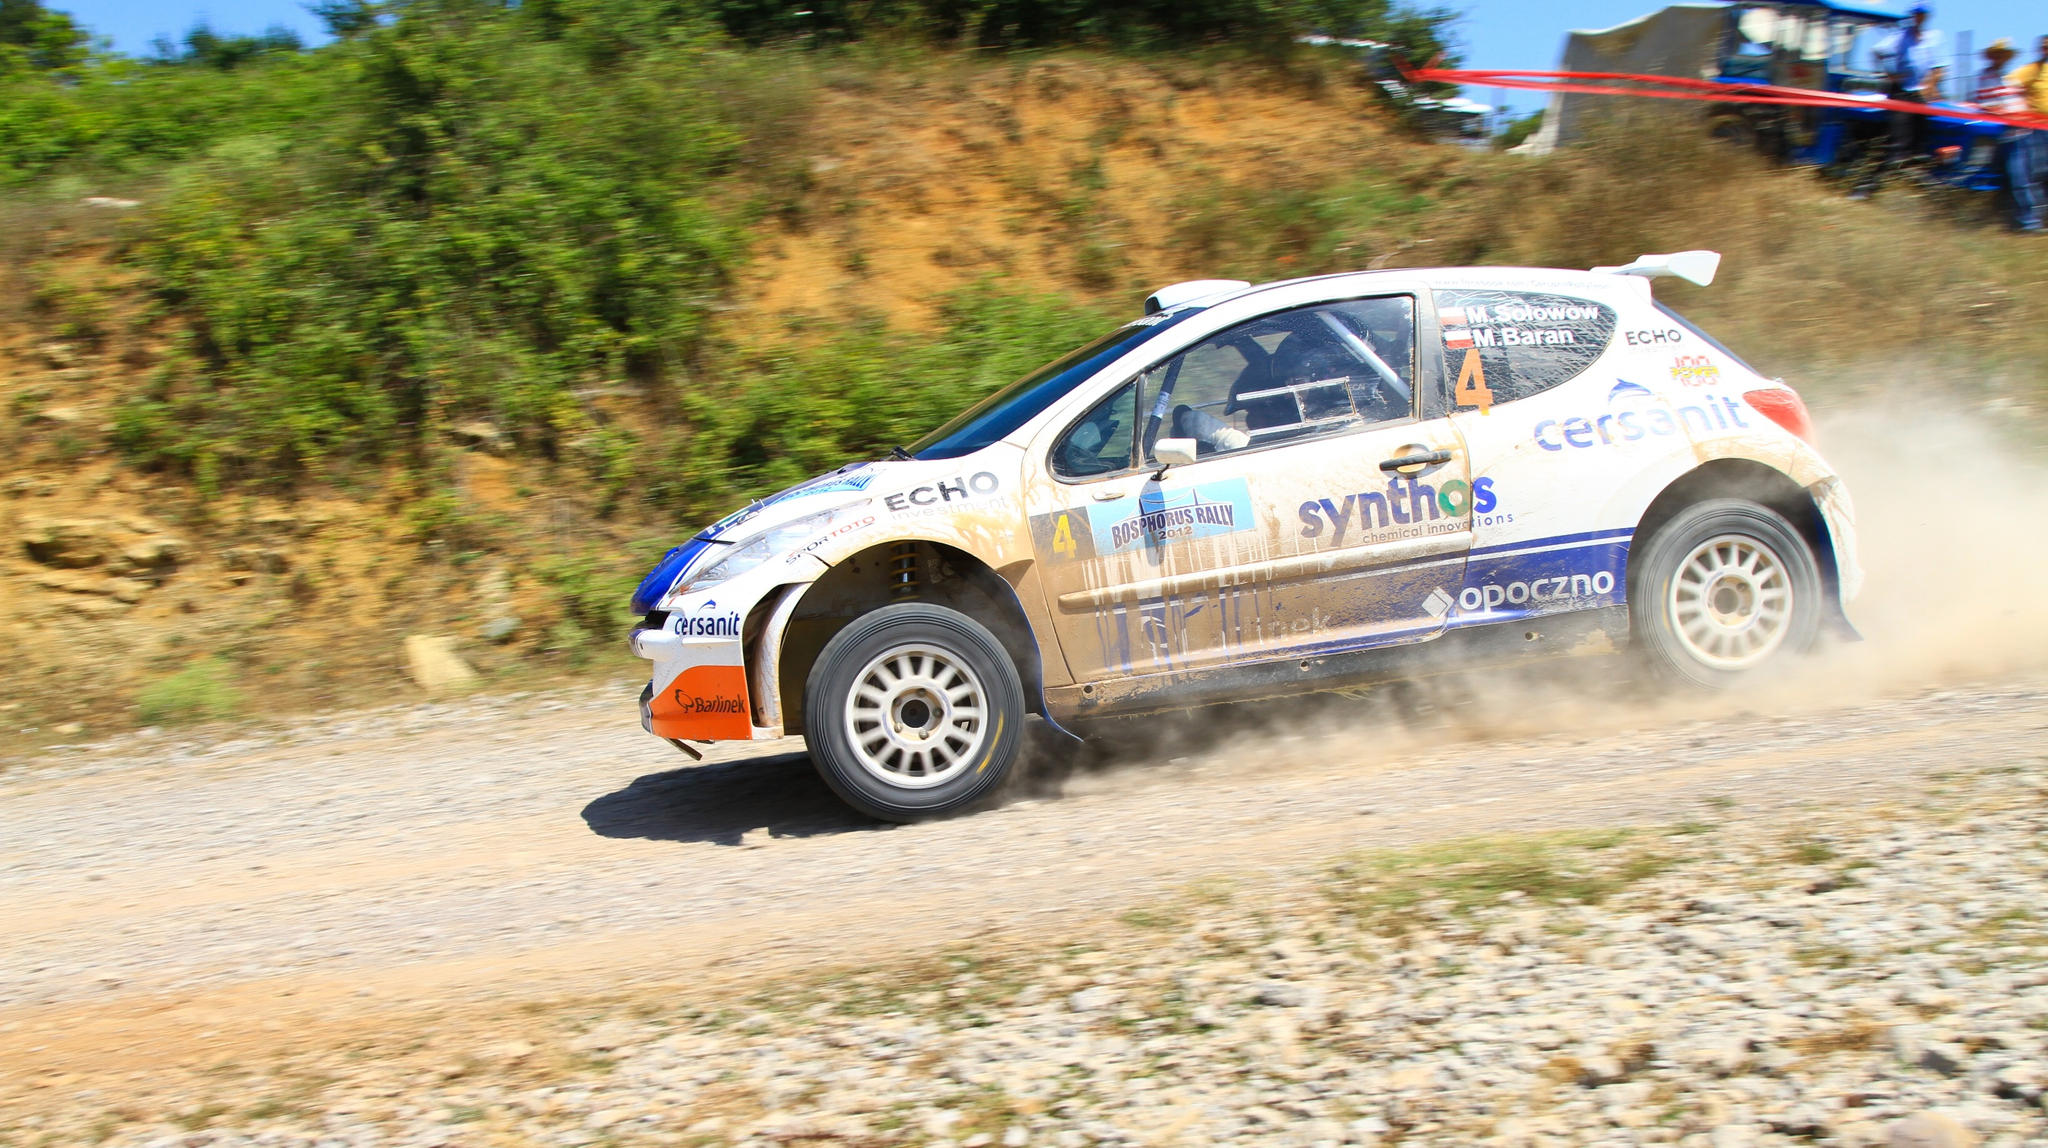Who might be the driver of this rally car? While the driver's identification isn't visible in this image, typically, cars in such competitions are piloted by experienced rally drivers who specialize in navigating diverse and challenging terrains. Rally drivers are often backed by a team that manages everything from car mechanics to navigation and strategy. 